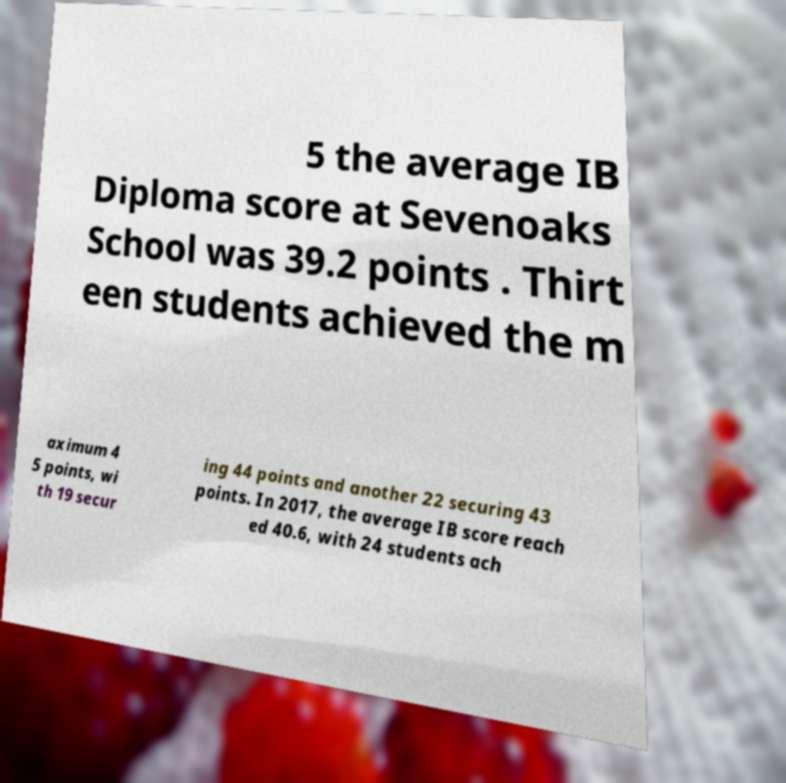Could you extract and type out the text from this image? 5 the average IB Diploma score at Sevenoaks School was 39.2 points . Thirt een students achieved the m aximum 4 5 points, wi th 19 secur ing 44 points and another 22 securing 43 points. In 2017, the average IB score reach ed 40.6, with 24 students ach 